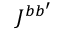<formula> <loc_0><loc_0><loc_500><loc_500>J ^ { b b ^ { \prime } }</formula> 